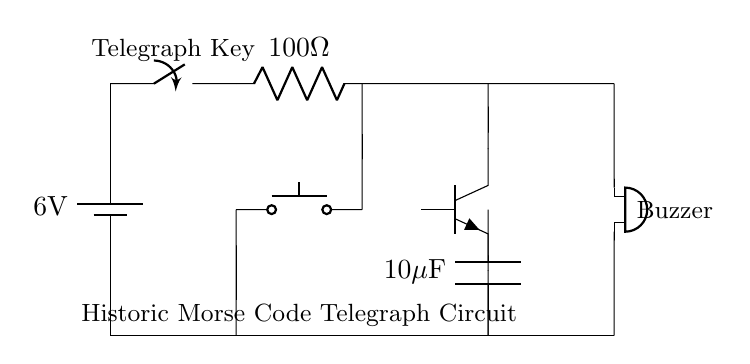What is the voltage of the battery? The voltage is indicated next to the battery component, showing a potential difference of 6V.
Answer: 6V What type of transistor is used in the circuit? The circuit shows an npn transistor symbol, which identifies the type of transistor used in this circuit.
Answer: npn How many ohms is the resistor in this circuit? The resistor value is denoted next to its symbol, revealing that it has a resistance of 100 ohms.
Answer: 100 ohm What component acts as the frequency determinant in this oscillator? The capacitor, alongside the resistor and transistor, influences the charge and discharge cycles, which determine the oscillation frequency in the circuit.
Answer: Capacitor Describe the function of the telegraph key in the circuit. The telegraph key is a push button switch that controls the flow of current, allowing for the transmission of Morse code signals when pressed.
Answer: Control current How does the buzzer produce sound when the telegraph key is pressed? When the telegraph key is pressed, it closes the circuit, allowing current to flow through the buzzer and causing it to produce sound due to the oscillating current induced by the capacitor and resistor circuit.
Answer: Produces sound What is the capacitance value in the circuit? The capacitance is explicitly labeled in the circuit diagram, indicating a value of 10 microfarads.
Answer: 10 microfarads 